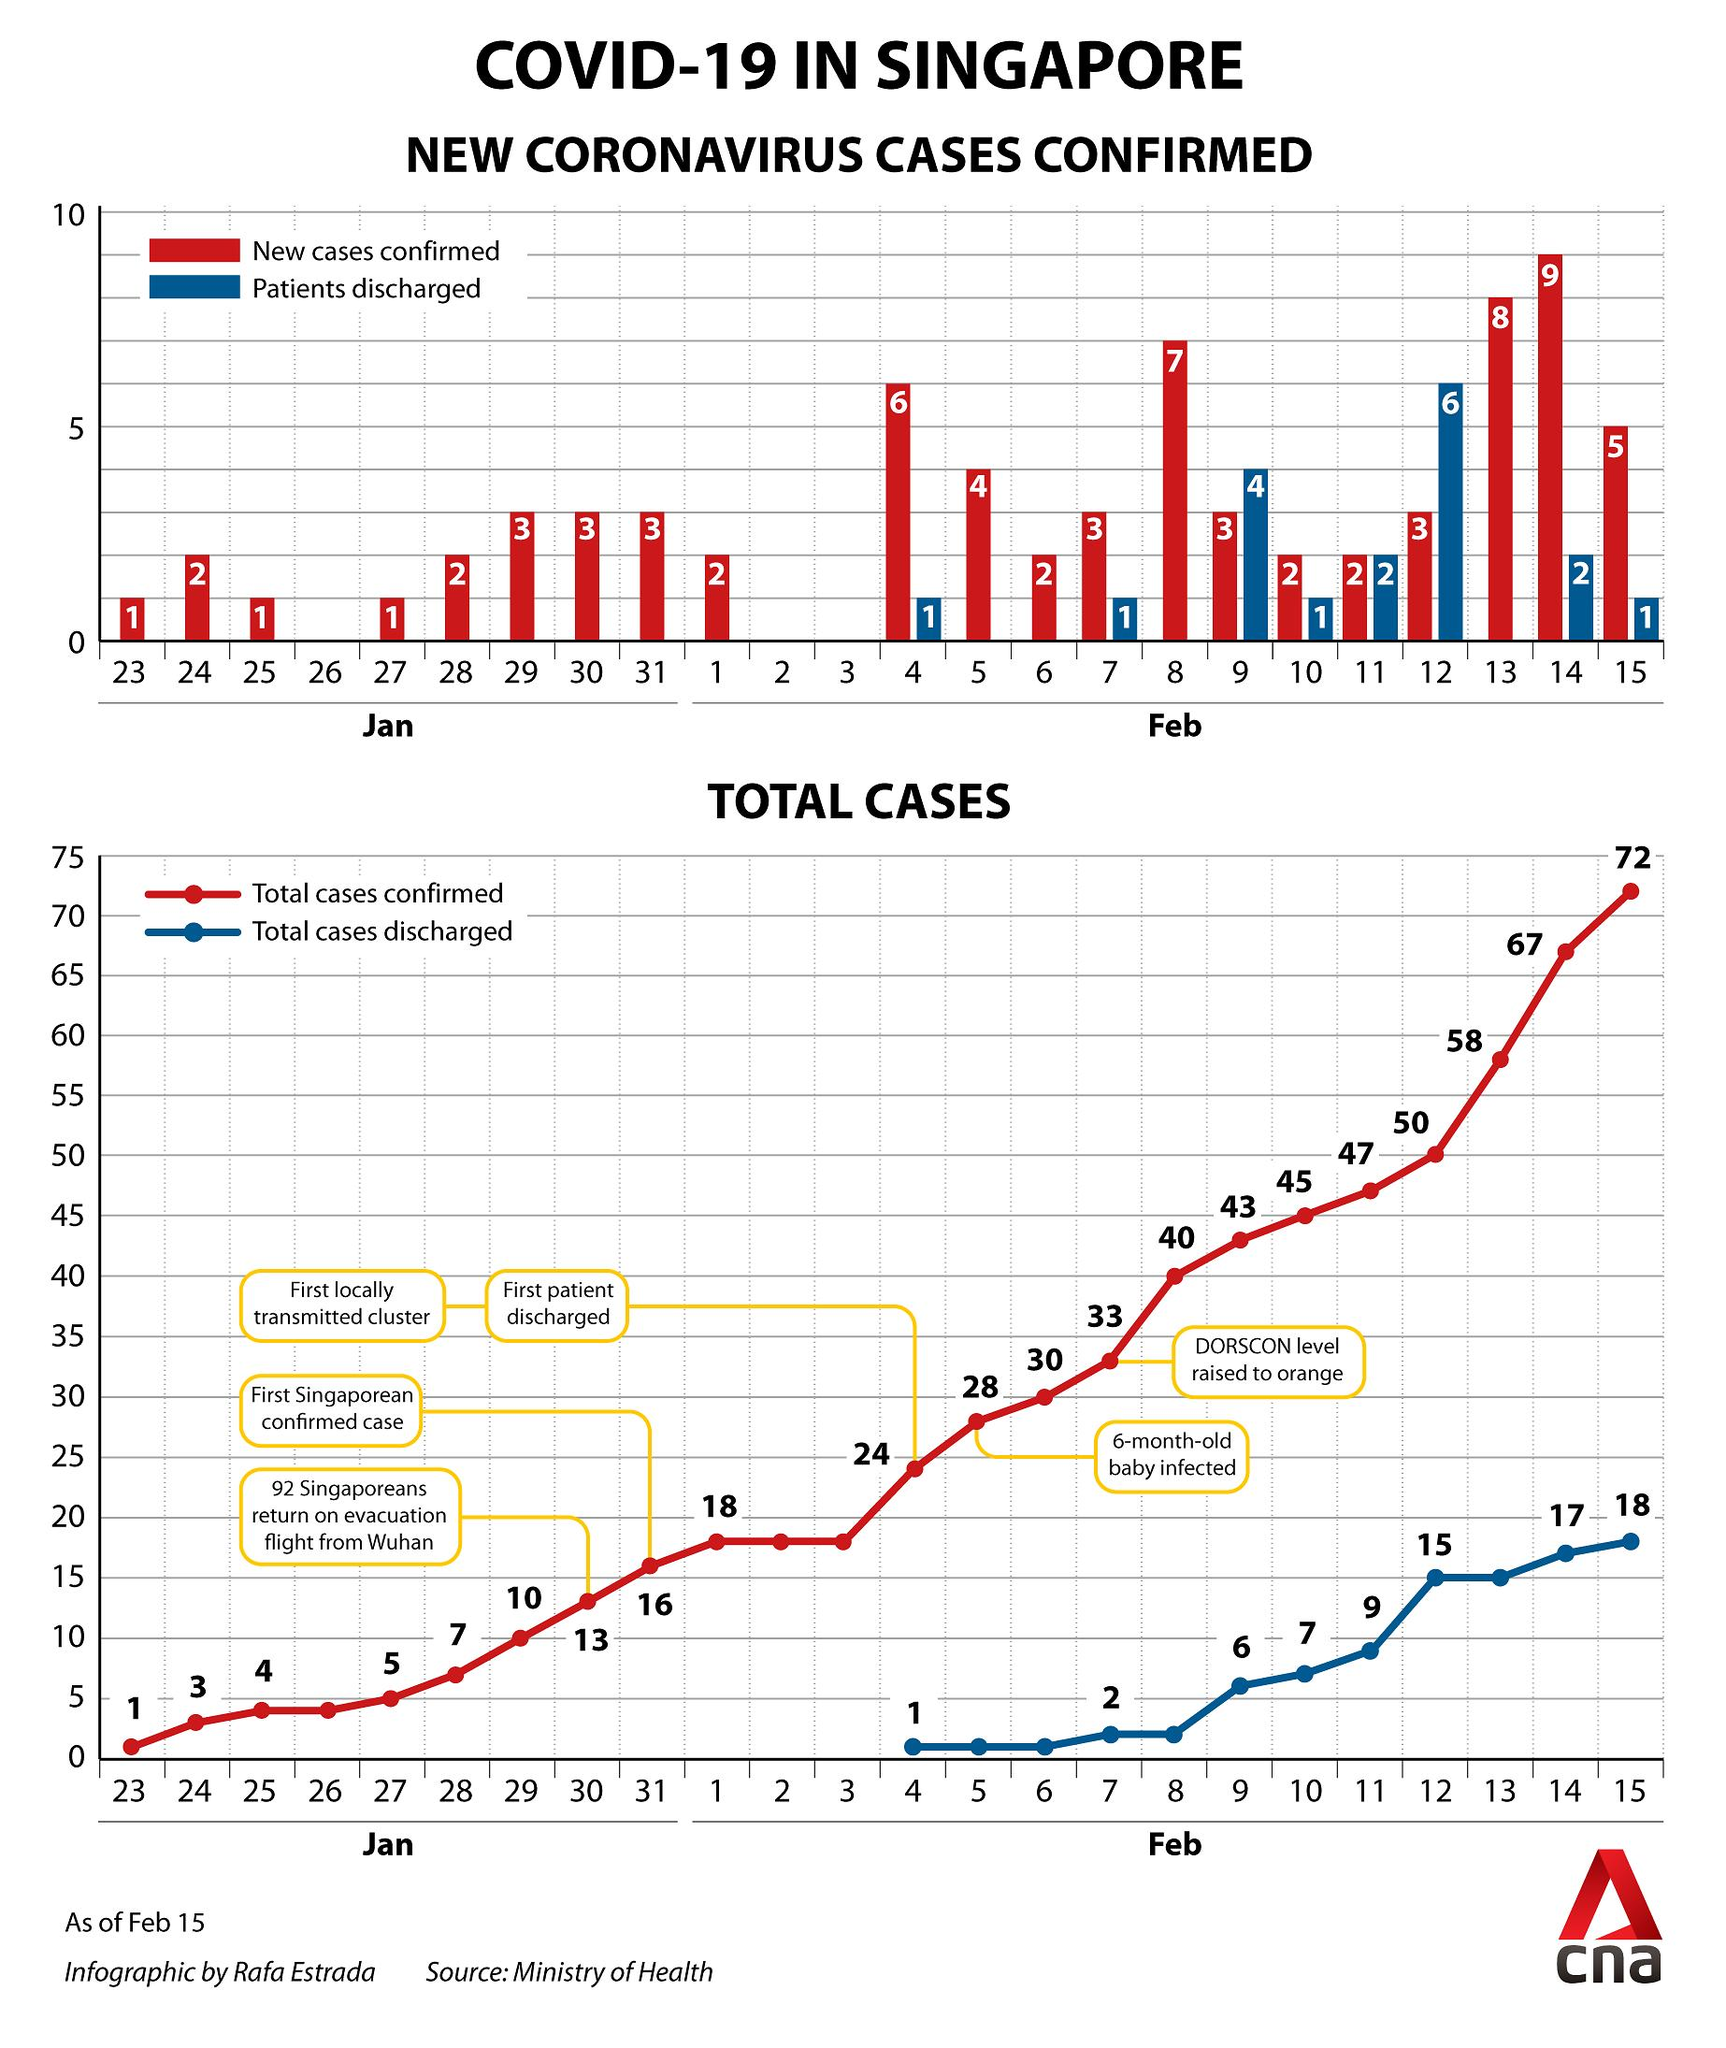Identify some key points in this picture. As of February 15, the total number of confirmed COVID-19 cases reported in Singapore is 72. As of February 13, the total number of confirmed COVID-19 cases reported in Singapore is 58. Eight new COVID-19 cases were confirmed in Singapore as of February 13. On February 4, the number of COVID-19 patients who were discharged from the Singapore hospitals was 1. A total of three new COVID-19 cases were confirmed in Singapore as of January 30. 